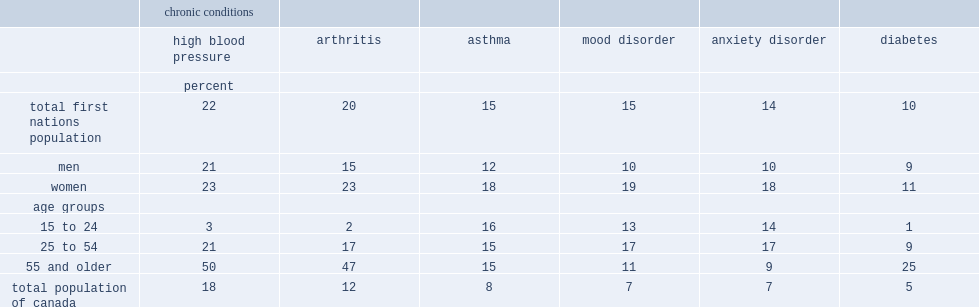Would you be able to parse every entry in this table? {'header': ['', 'chronic conditions', '', '', '', '', ''], 'rows': [['', 'high blood pressure', 'arthritis', 'asthma', 'mood disorder', 'anxiety disorder', 'diabetes'], ['', 'percent', '', '', '', '', ''], ['total first nations population', '22', '20', '15', '15', '14', '10'], ['men', '21', '15', '12', '10', '10', '9'], ['women', '23', '23', '18', '19', '18', '11'], ['age groups', '', '', '', '', '', ''], ['15 to 24', '3', '2', '16', '13', '14', '1'], ['25 to 54', '21', '17', '15', '17', '17', '9'], ['55 and older', '50', '47', '15', '11', '9', '25'], ['total population of canada', '18', '12', '8', '7', '7', '5']]} What was the proportion of first nations people that had high blood pressure in 2012? 22.0. What was the proportion of first nations people that had arthritis in 2012? 20.0. What was the proportion of first nations people that had asthma in 2012? 15.0. What was the proportion of male first nations people that had arthritis in 2012? 15.0. What was the proportion of female first nations people that had arthritis in 2012? 23.0. In 2012, which gender had a higher proportion with arthritis? Women. What was the proportion of male first nations people that had asthma in 2012? 12.0. What was the proportion of female first nations people that had asthma in 2012? 18.0. In 2012, which gender had a higher proportion with asthma? Women. What was the proportion of male first nations people that had mood disorder in 2012? 10.0. What was the proportion of female first nations people that had mood disorder in 2012? 19.0. In 2012, which gender had a higher proportion with mood disorder? Women. What was the proportion of male first nations people that had anxiety disorder in 2012? 10.0. What was the proportion of female first nations people that had anxiety disorder in 2012? 18.0. What was the proportion of first nations people that had diabetes in 2012? 10.0. 